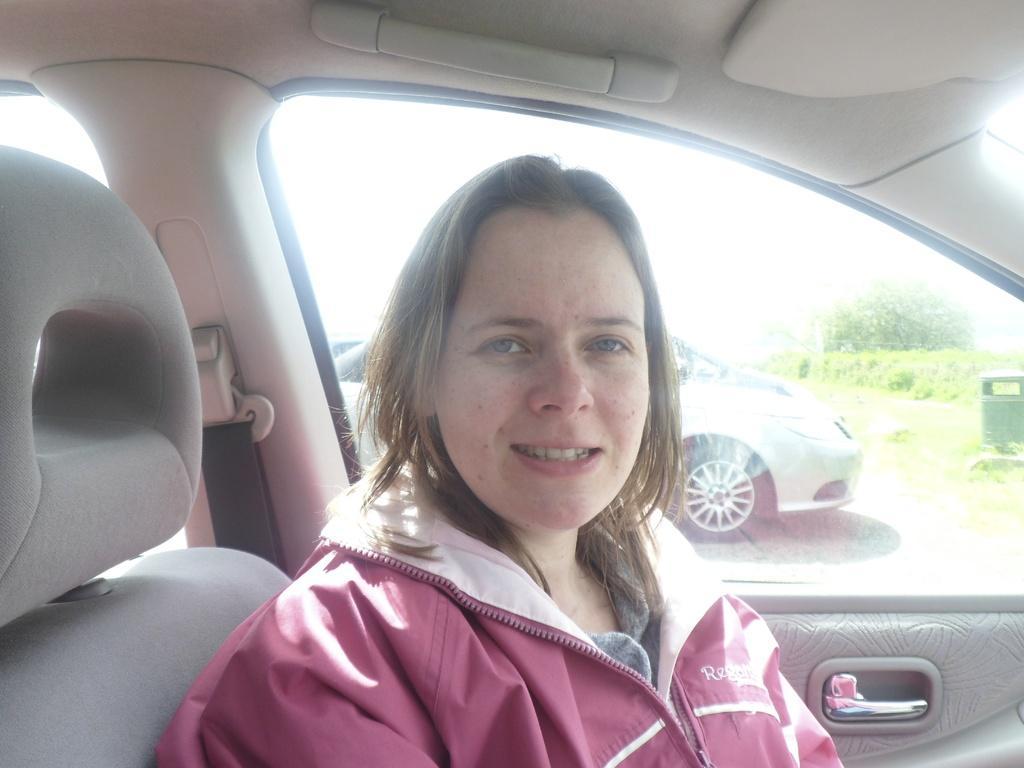How would you summarize this image in a sentence or two? This picture shows a woman sitting in a seat, inside a car. In the background, we can observe a car and some trees here. 